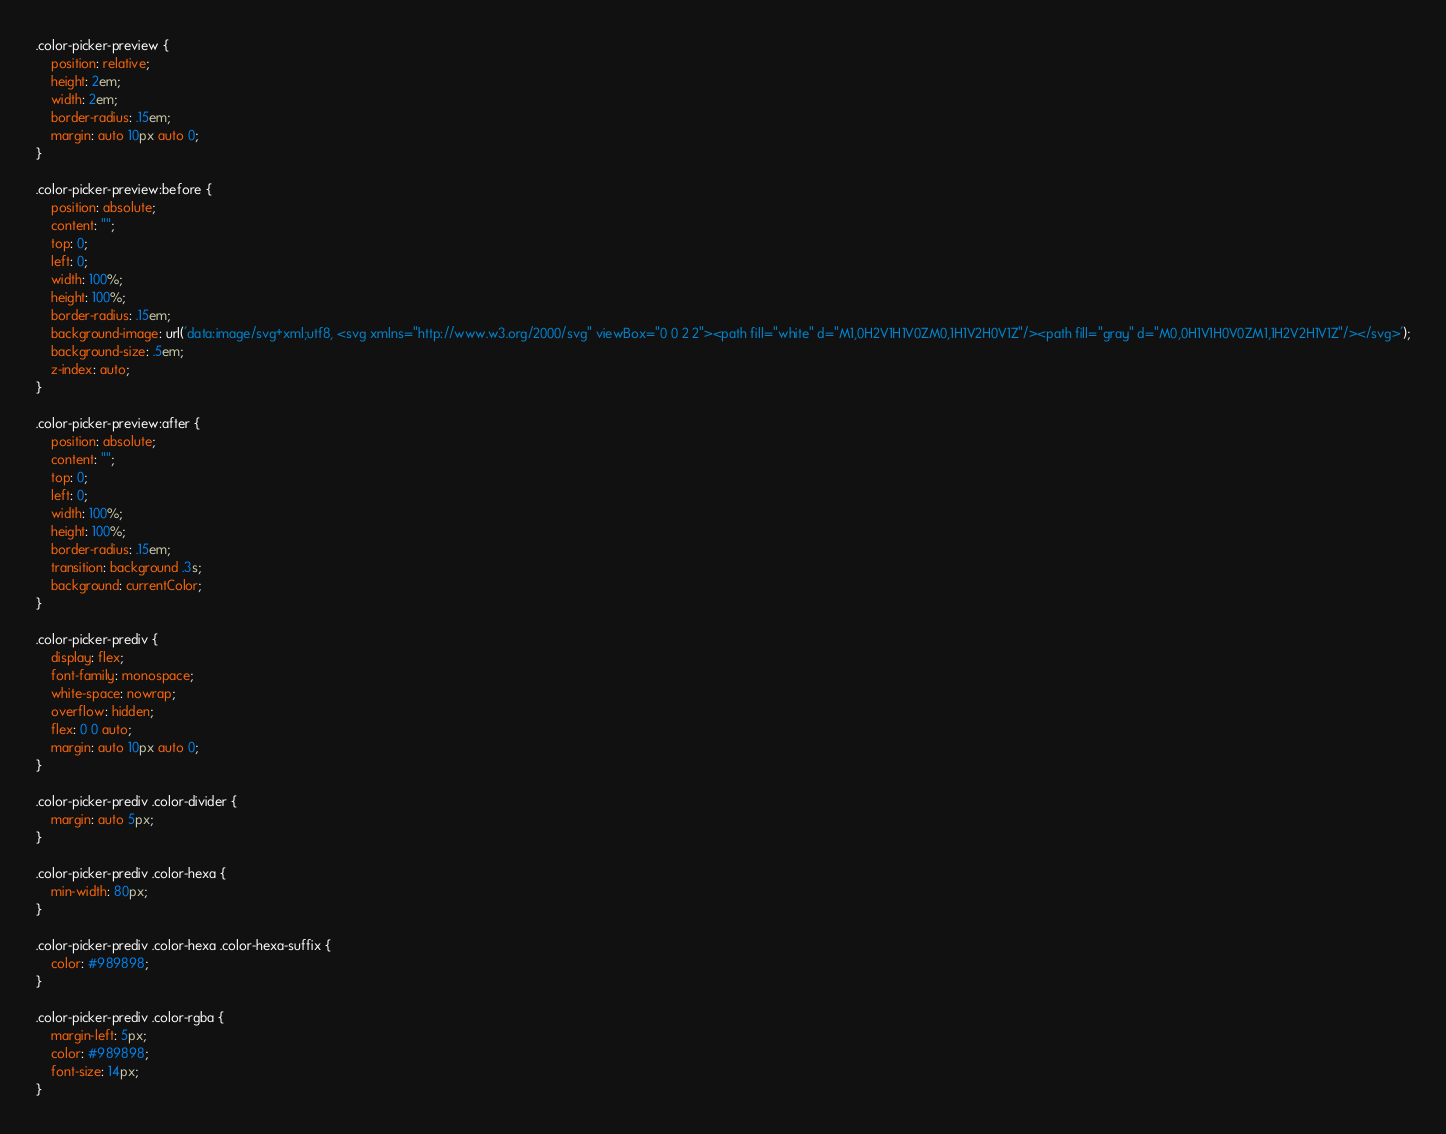Convert code to text. <code><loc_0><loc_0><loc_500><loc_500><_CSS_>.color-picker-preview {
    position: relative;
    height: 2em;
    width: 2em;
    border-radius: .15em;
    margin: auto 10px auto 0;
}

.color-picker-preview:before {
    position: absolute;
    content: "";
    top: 0;
    left: 0;
    width: 100%;
    height: 100%;
    border-radius: .15em;
    background-image: url('data:image/svg+xml;utf8, <svg xmlns="http://www.w3.org/2000/svg" viewBox="0 0 2 2"><path fill="white" d="M1,0H2V1H1V0ZM0,1H1V2H0V1Z"/><path fill="gray" d="M0,0H1V1H0V0ZM1,1H2V2H1V1Z"/></svg>');
    background-size: .5em;
    z-index: auto;
}

.color-picker-preview:after {
    position: absolute;
    content: "";
    top: 0;
    left: 0;
    width: 100%;
    height: 100%;
    border-radius: .15em;
    transition: background .3s;
    background: currentColor;
}

.color-picker-prediv {
    display: flex;
    font-family: monospace;
    white-space: nowrap;
    overflow: hidden;
    flex: 0 0 auto;
    margin: auto 10px auto 0;
}

.color-picker-prediv .color-divider {
    margin: auto 5px;
}

.color-picker-prediv .color-hexa {
    min-width: 80px;
}

.color-picker-prediv .color-hexa .color-hexa-suffix {
    color: #989898;
}

.color-picker-prediv .color-rgba {
    margin-left: 5px;
    color: #989898;
    font-size: 14px;
}</code> 